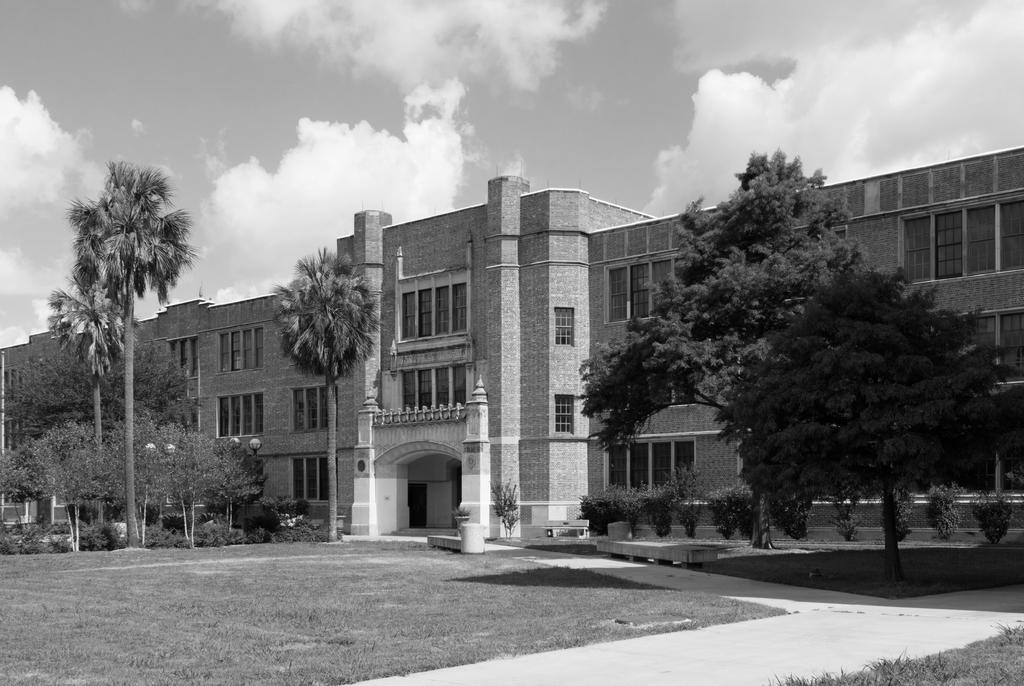What type of vegetation is on the left side of the image? There are trees on the left side of the image. What structure can be seen in the image? There is a building in the image. What is visible at the top of the image? The sky is visible at the top of the image. What type of teaching method is being used in the image? There is no teaching or educational context present in the image. What material is the building made of in the image? The provided facts do not mention the material of the building, so we cannot determine if it is made of brick or any other material. 